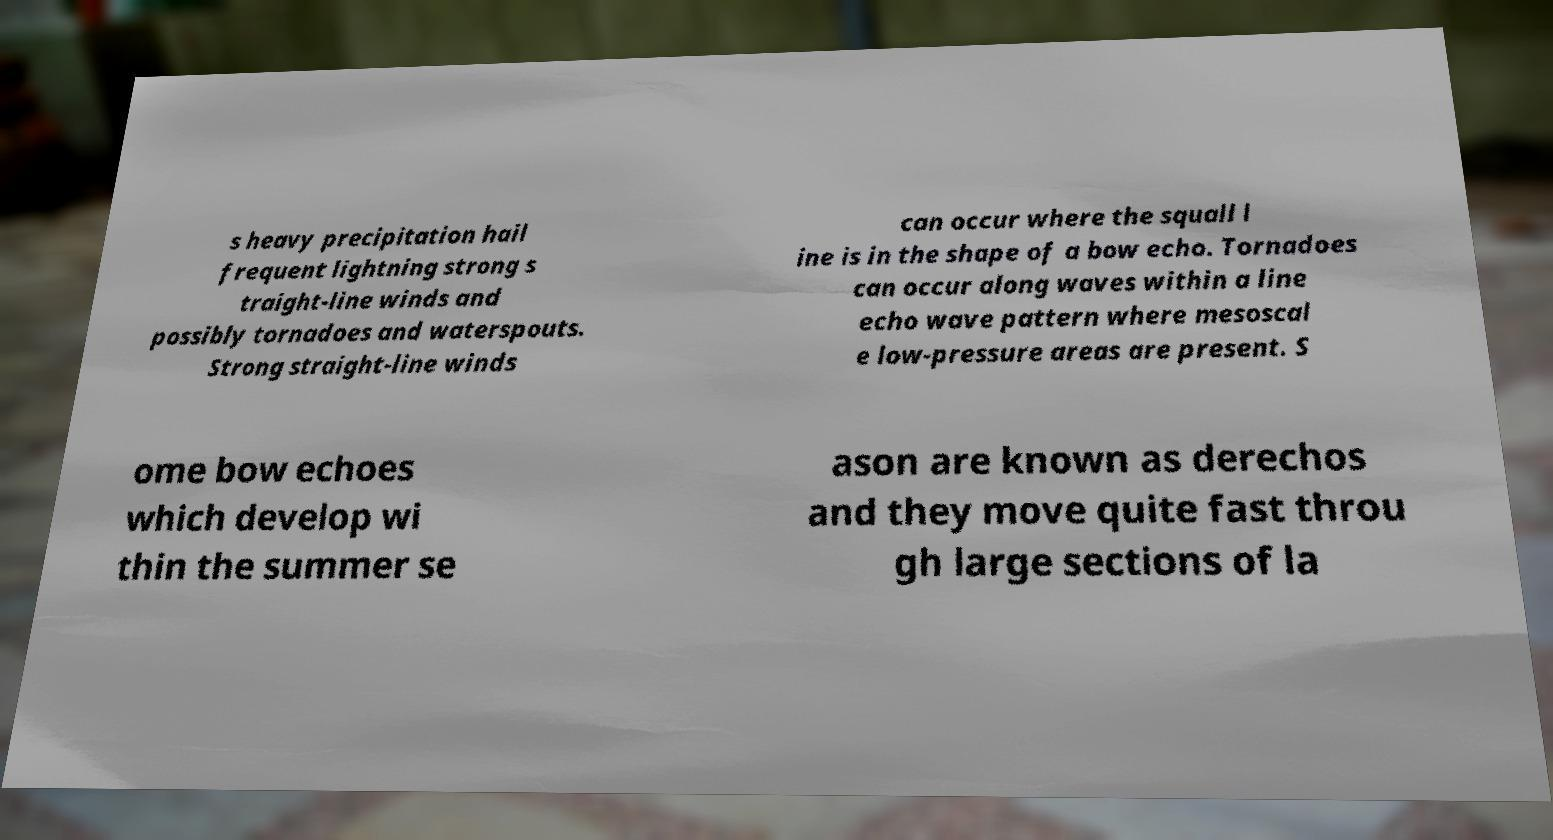Could you extract and type out the text from this image? s heavy precipitation hail frequent lightning strong s traight-line winds and possibly tornadoes and waterspouts. Strong straight-line winds can occur where the squall l ine is in the shape of a bow echo. Tornadoes can occur along waves within a line echo wave pattern where mesoscal e low-pressure areas are present. S ome bow echoes which develop wi thin the summer se ason are known as derechos and they move quite fast throu gh large sections of la 